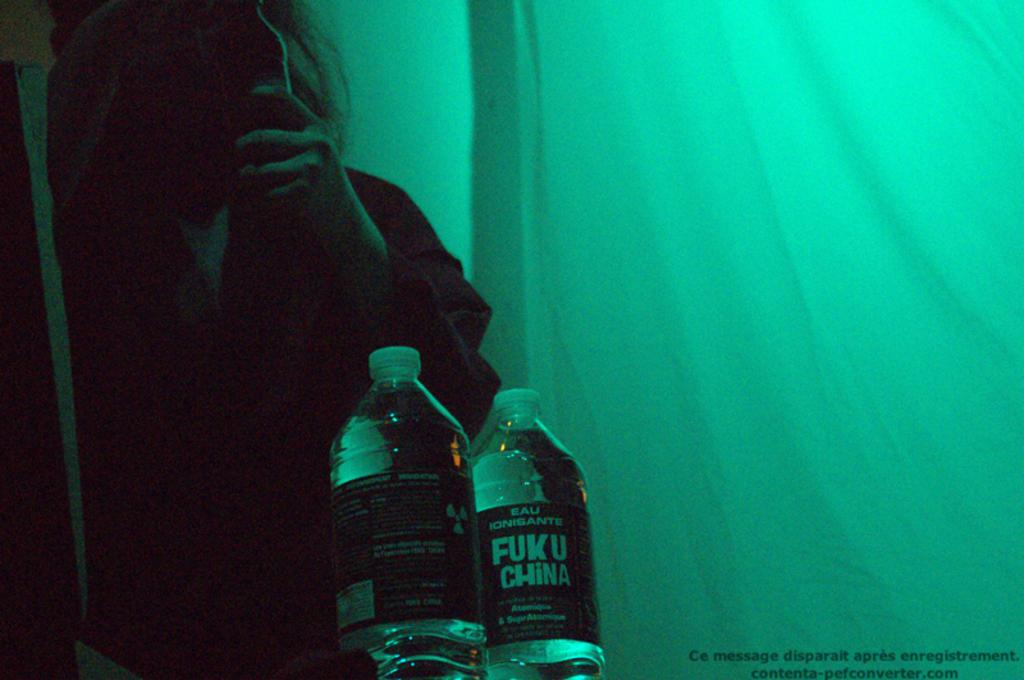Provide a one-sentence caption for the provided image. A person holds their phone to their face in a green tent with two water bottles, one of which has a label that says FUK U CHINA. 